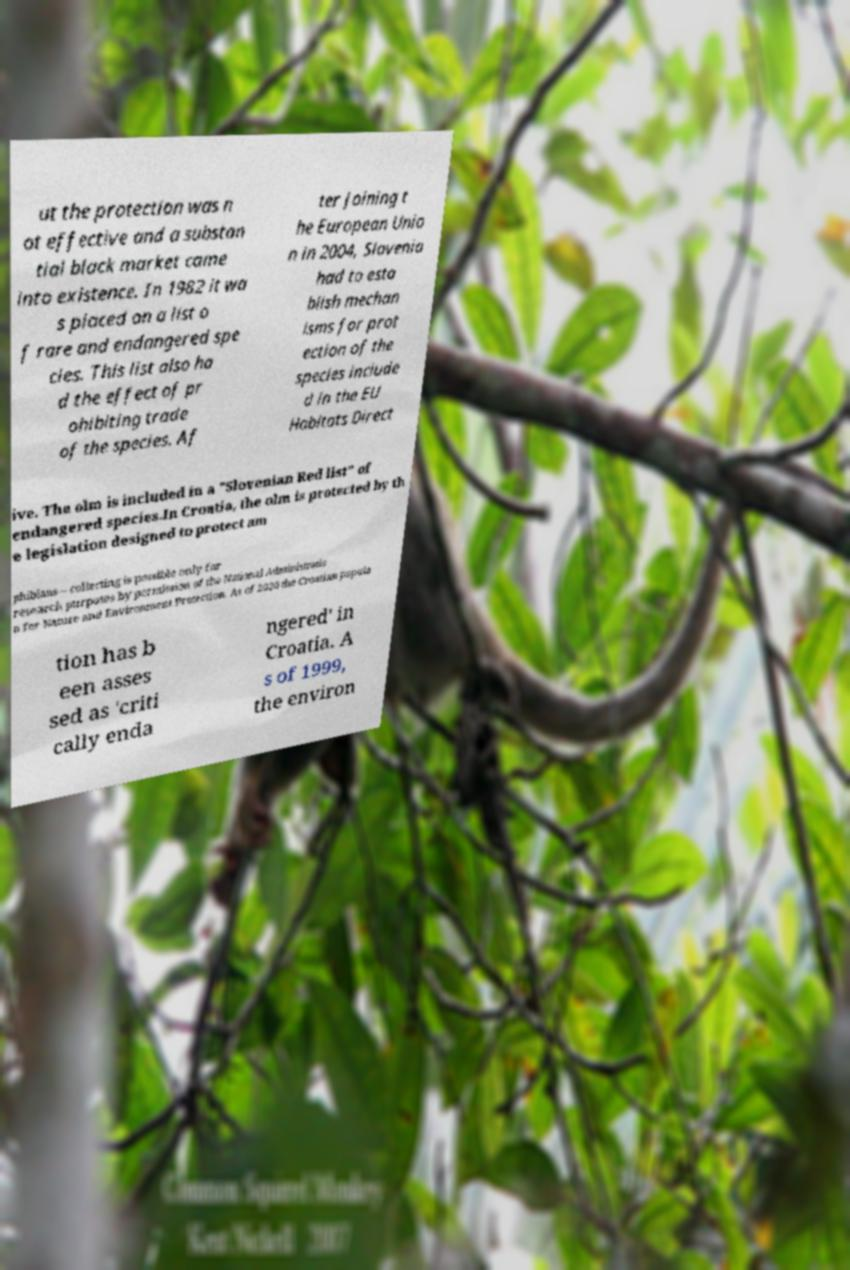There's text embedded in this image that I need extracted. Can you transcribe it verbatim? ut the protection was n ot effective and a substan tial black market came into existence. In 1982 it wa s placed on a list o f rare and endangered spe cies. This list also ha d the effect of pr ohibiting trade of the species. Af ter joining t he European Unio n in 2004, Slovenia had to esta blish mechan isms for prot ection of the species include d in the EU Habitats Direct ive. The olm is included in a "Slovenian Red list" of endangered species.In Croatia, the olm is protected by th e legislation designed to protect am phibians – collecting is possible only for research purposes by permission of the National Administratio n for Nature and Environment Protection. As of 2020 the Croatian popula tion has b een asses sed as 'criti cally enda ngered' in Croatia. A s of 1999, the environ 